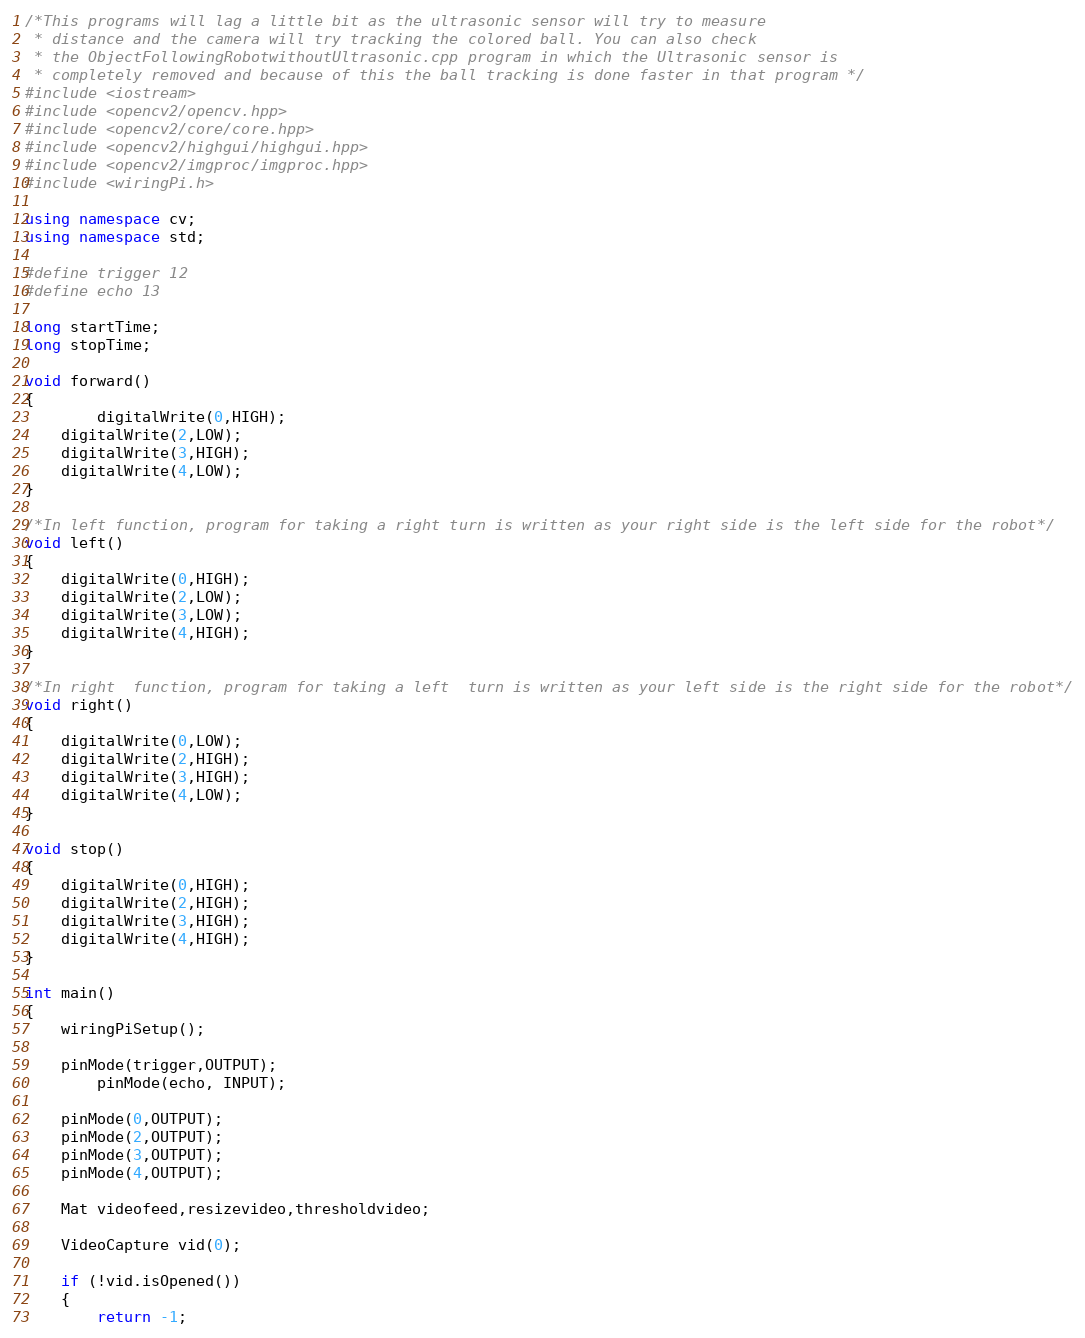Convert code to text. <code><loc_0><loc_0><loc_500><loc_500><_C++_>/*This programs will lag a little bit as the ultrasonic sensor will try to measure
 * distance and the camera will try tracking the colored ball. You can also check 
 * the ObjectFollowingRobotwithoutUltrasonic.cpp program in which the Ultrasonic sensor is 
 * completely removed and because of this the ball tracking is done faster in that program */
#include <iostream>
#include <opencv2/opencv.hpp>
#include <opencv2/core/core.hpp>
#include <opencv2/highgui/highgui.hpp>
#include <opencv2/imgproc/imgproc.hpp>
#include <wiringPi.h>

using namespace cv;
using namespace std;

#define trigger 12
#define echo 13

long startTime;
long stopTime;

void forward()
{
        digitalWrite(0,HIGH);
	digitalWrite(2,LOW);
	digitalWrite(3,HIGH);
	digitalWrite(4,LOW);
}

/*In left function, program for taking a right turn is written as your right side is the left side for the robot*/
void left()
{
	digitalWrite(0,HIGH);
	digitalWrite(2,LOW);
	digitalWrite(3,LOW);
	digitalWrite(4,HIGH);
}

/*In right  function, program for taking a left  turn is written as your left side is the right side for the robot*/
void right()
{
	digitalWrite(0,LOW);
	digitalWrite(2,HIGH);
	digitalWrite(3,HIGH);
	digitalWrite(4,LOW);
}

void stop()
{
    digitalWrite(0,HIGH);
	digitalWrite(2,HIGH);
	digitalWrite(3,HIGH);
	digitalWrite(4,HIGH);
}

int main()
{
	wiringPiSetup();
	
	pinMode(trigger,OUTPUT);
        pinMode(echo, INPUT); 
    
	pinMode(0,OUTPUT);
	pinMode(2,OUTPUT);
	pinMode(3,OUTPUT);
	pinMode(4,OUTPUT);
	
	Mat videofeed,resizevideo,thresholdvideo;
	
	VideoCapture vid(0);
	
	if (!vid.isOpened())
	{
		return -1;</code> 